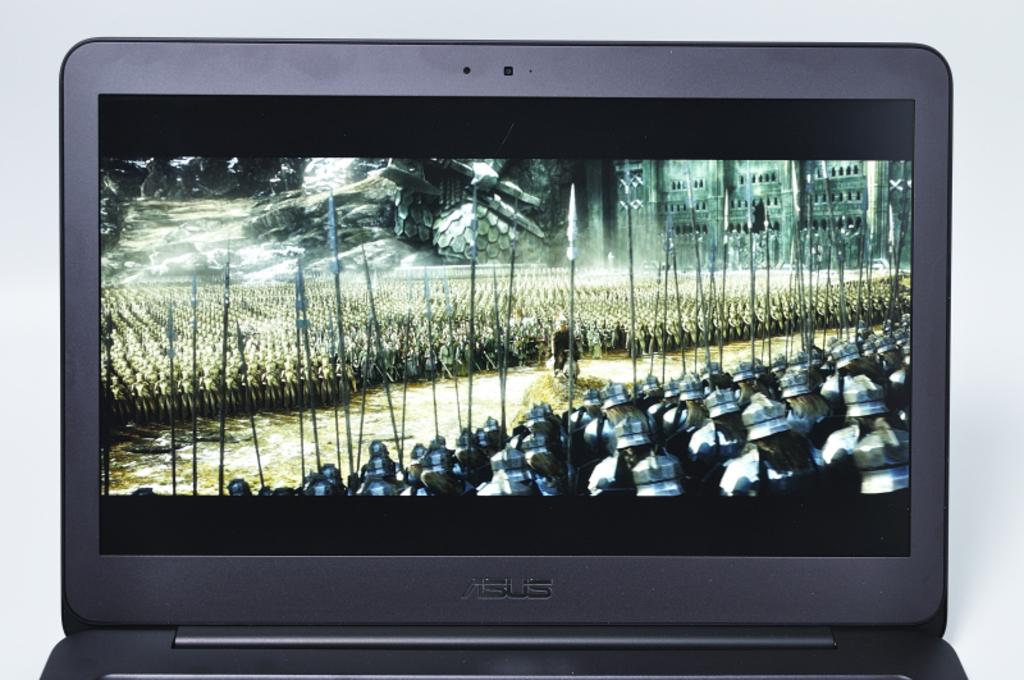<image>
Summarize the visual content of the image. A picture of many soldiers on the display of an ASUS laptop 